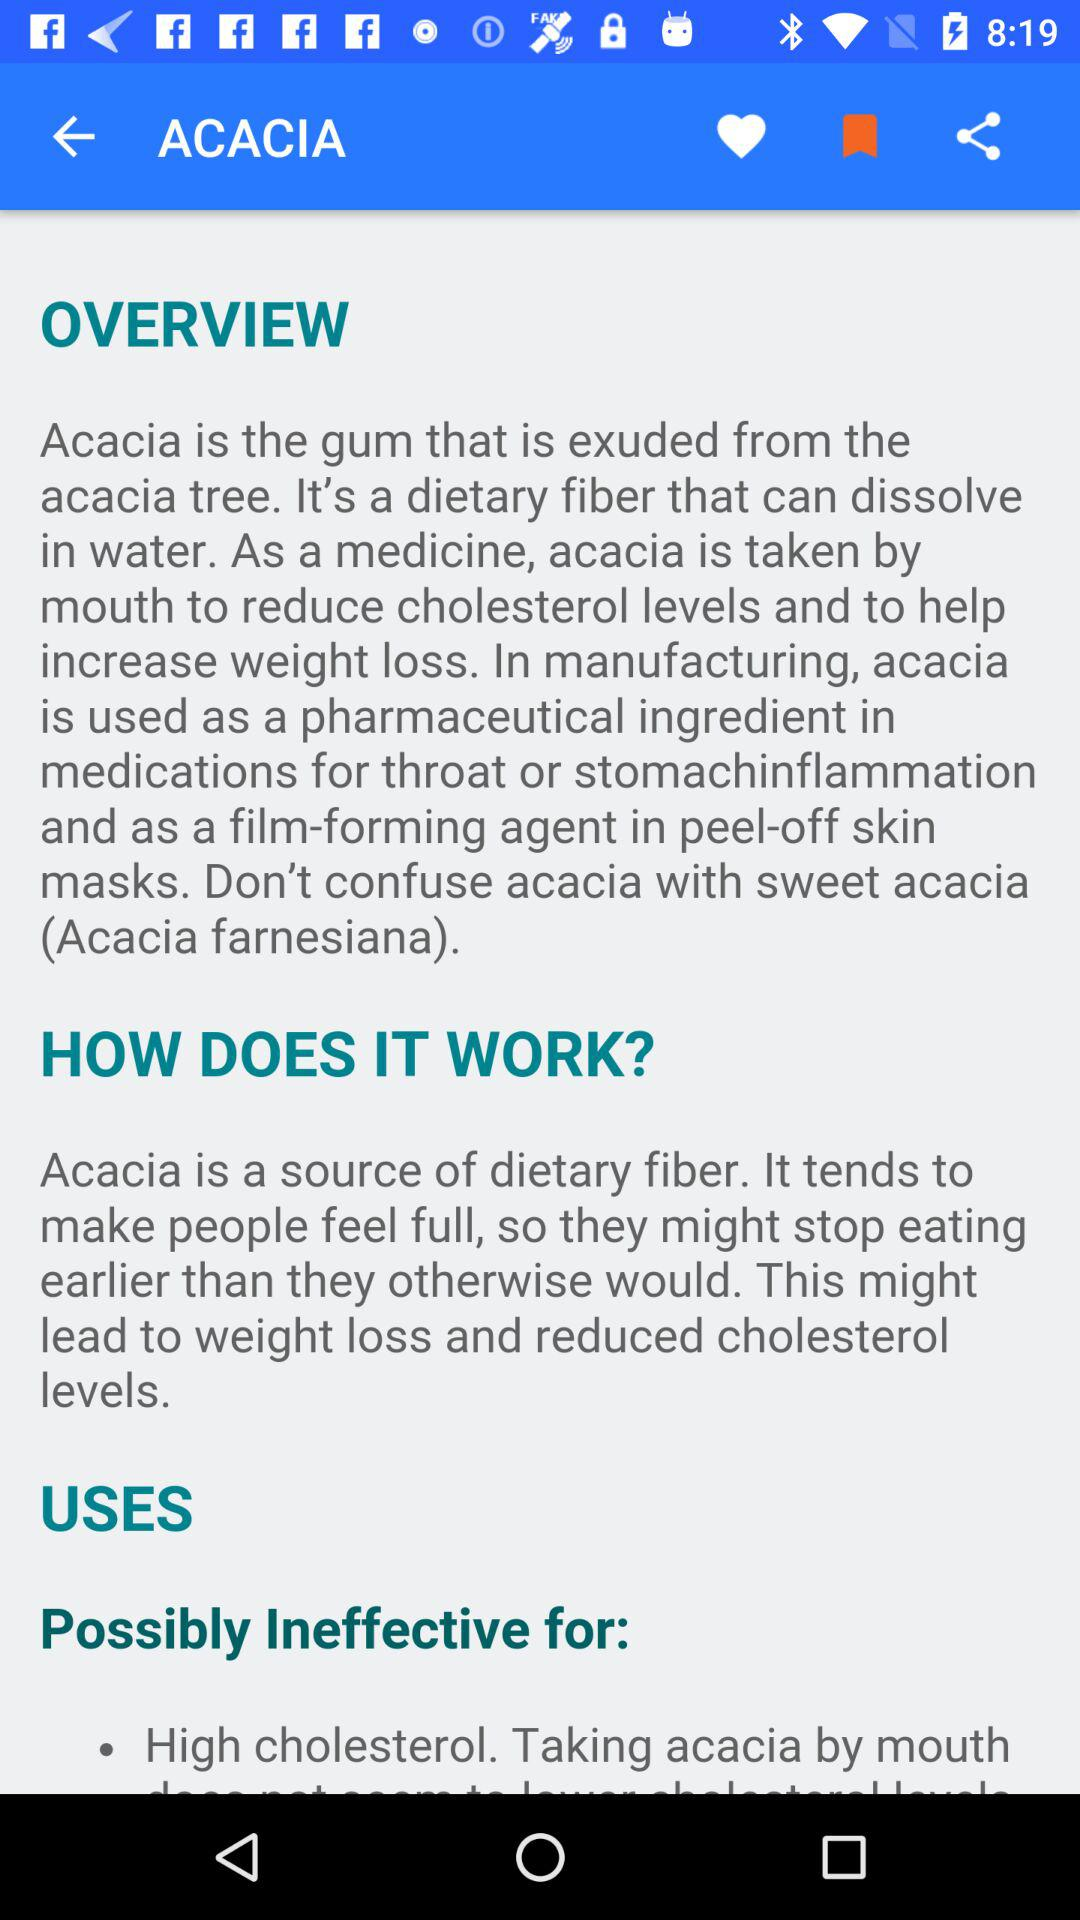What are the advantages of using Acacia as a medicine? The advantages of using Acacia as a medicine are that it helps to reduce cholesterol levels and increase weight loss. 